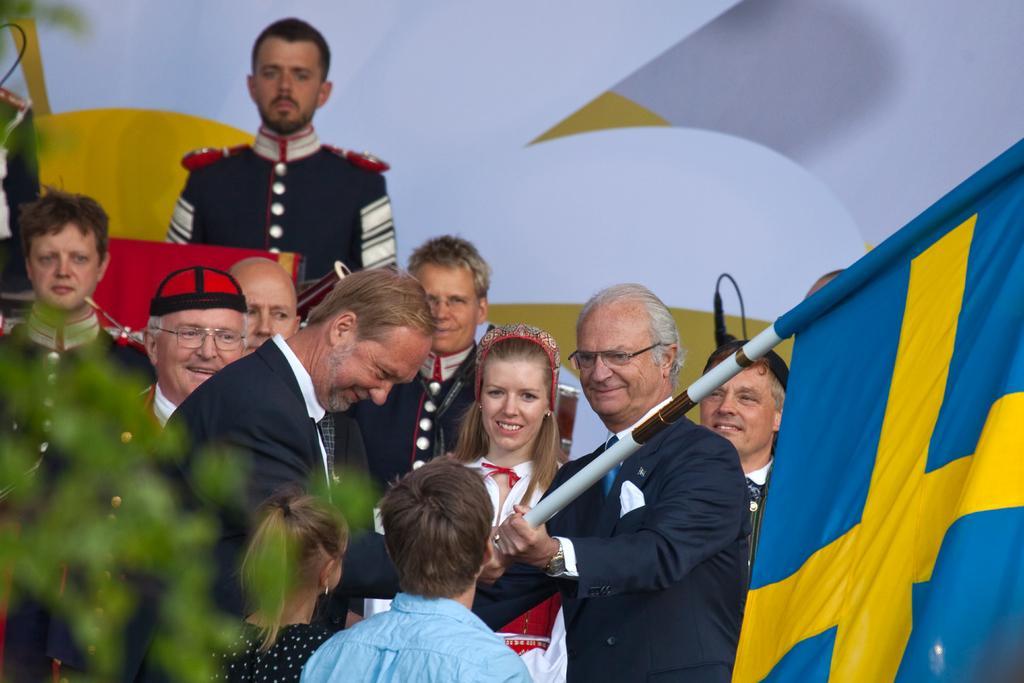In one or two sentences, can you explain what this image depicts? In this image there are a group of people and there are some persons who are holding a pole and flag, and on the left side there is a plant. And in the background there are some boards and some objects. 